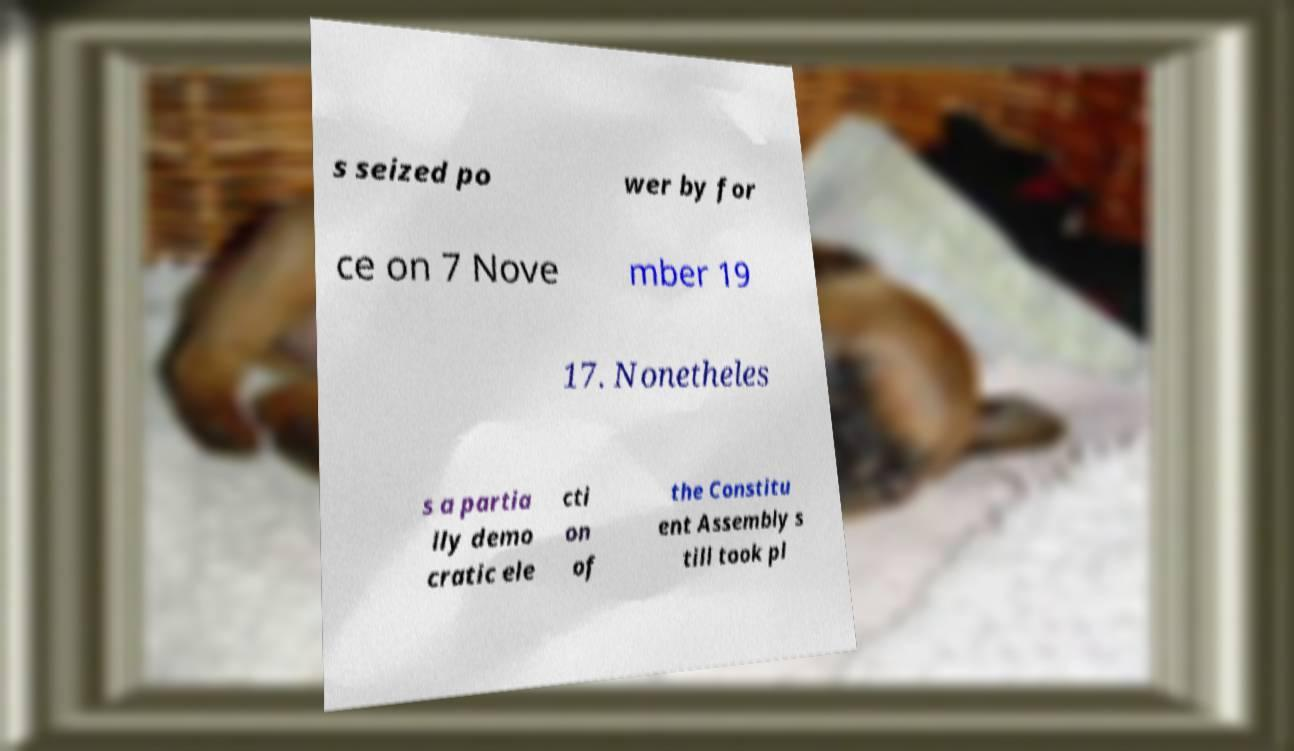Could you extract and type out the text from this image? s seized po wer by for ce on 7 Nove mber 19 17. Nonetheles s a partia lly demo cratic ele cti on of the Constitu ent Assembly s till took pl 